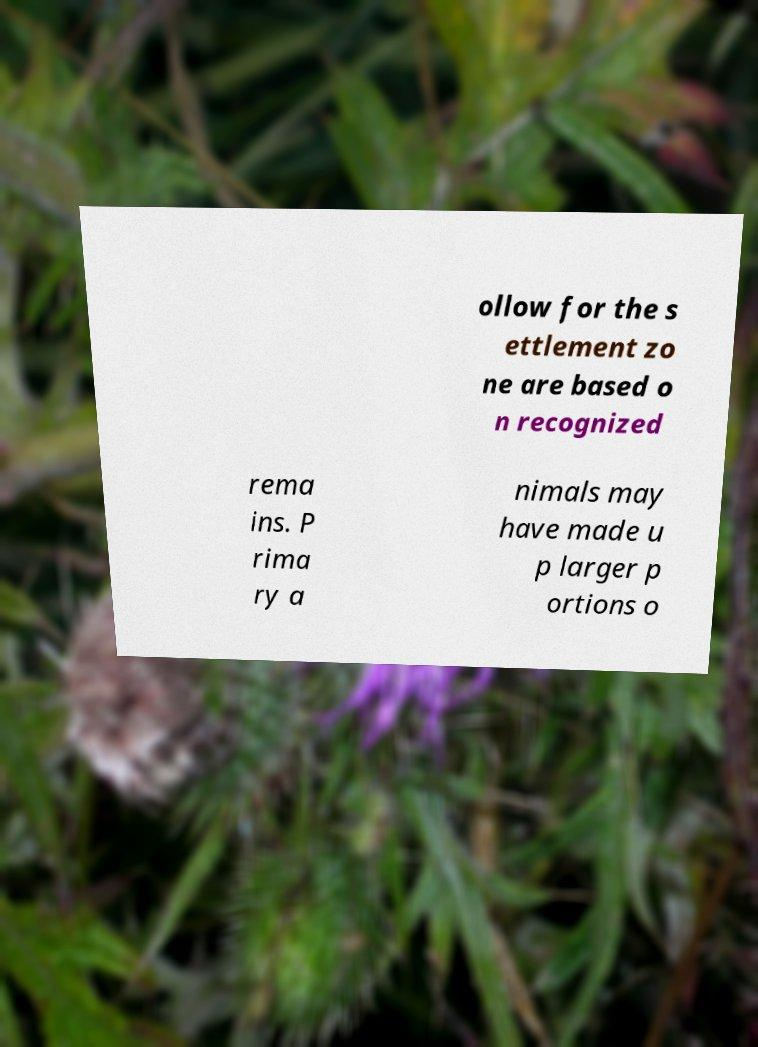Can you read and provide the text displayed in the image?This photo seems to have some interesting text. Can you extract and type it out for me? ollow for the s ettlement zo ne are based o n recognized rema ins. P rima ry a nimals may have made u p larger p ortions o 